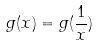<formula> <loc_0><loc_0><loc_500><loc_500>g ( x ) = g ( \frac { 1 } { x } )</formula> 